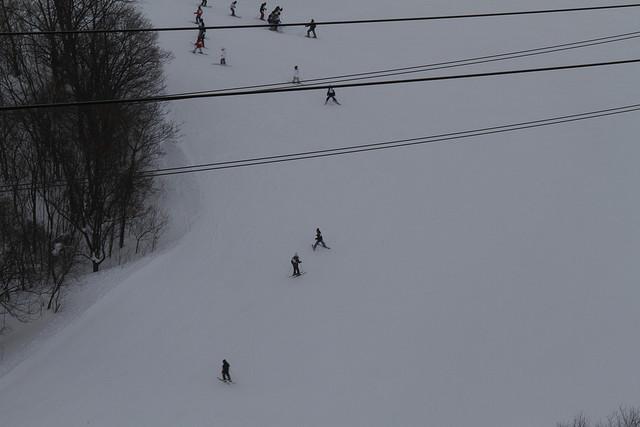How many cats are there?
Give a very brief answer. 0. 